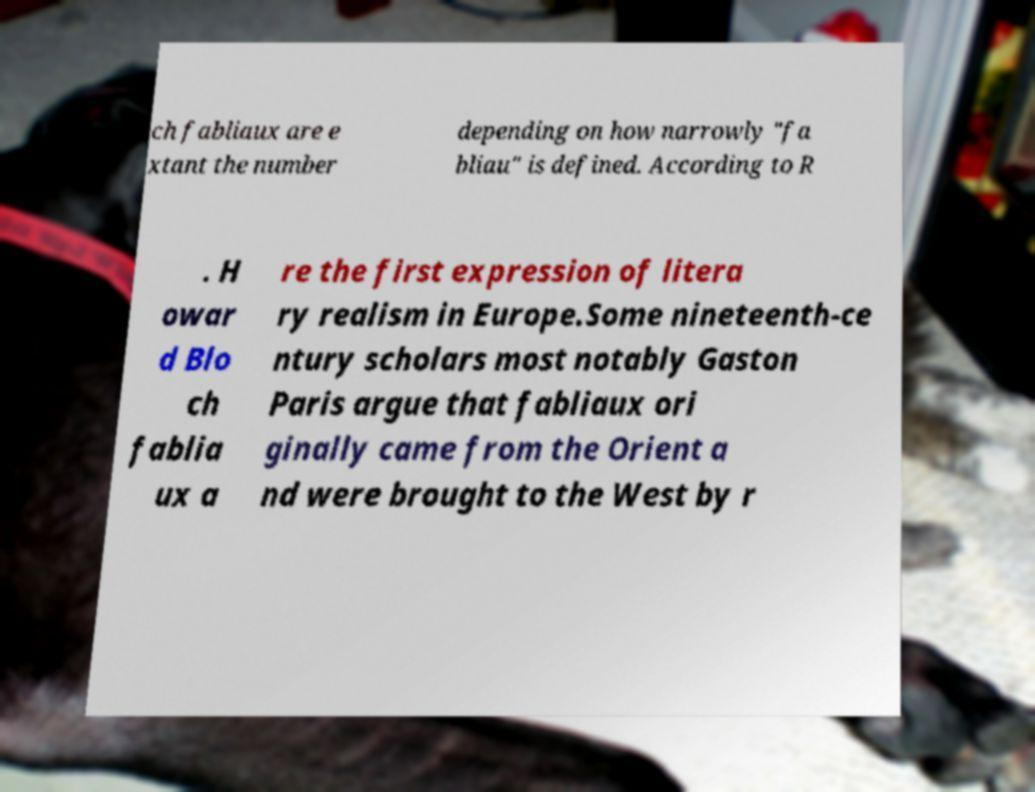Can you read and provide the text displayed in the image?This photo seems to have some interesting text. Can you extract and type it out for me? ch fabliaux are e xtant the number depending on how narrowly "fa bliau" is defined. According to R . H owar d Blo ch fablia ux a re the first expression of litera ry realism in Europe.Some nineteenth-ce ntury scholars most notably Gaston Paris argue that fabliaux ori ginally came from the Orient a nd were brought to the West by r 